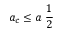<formula> <loc_0><loc_0><loc_500><loc_500>a _ { c } \leq a \ \frac { 1 } { 2 }</formula> 